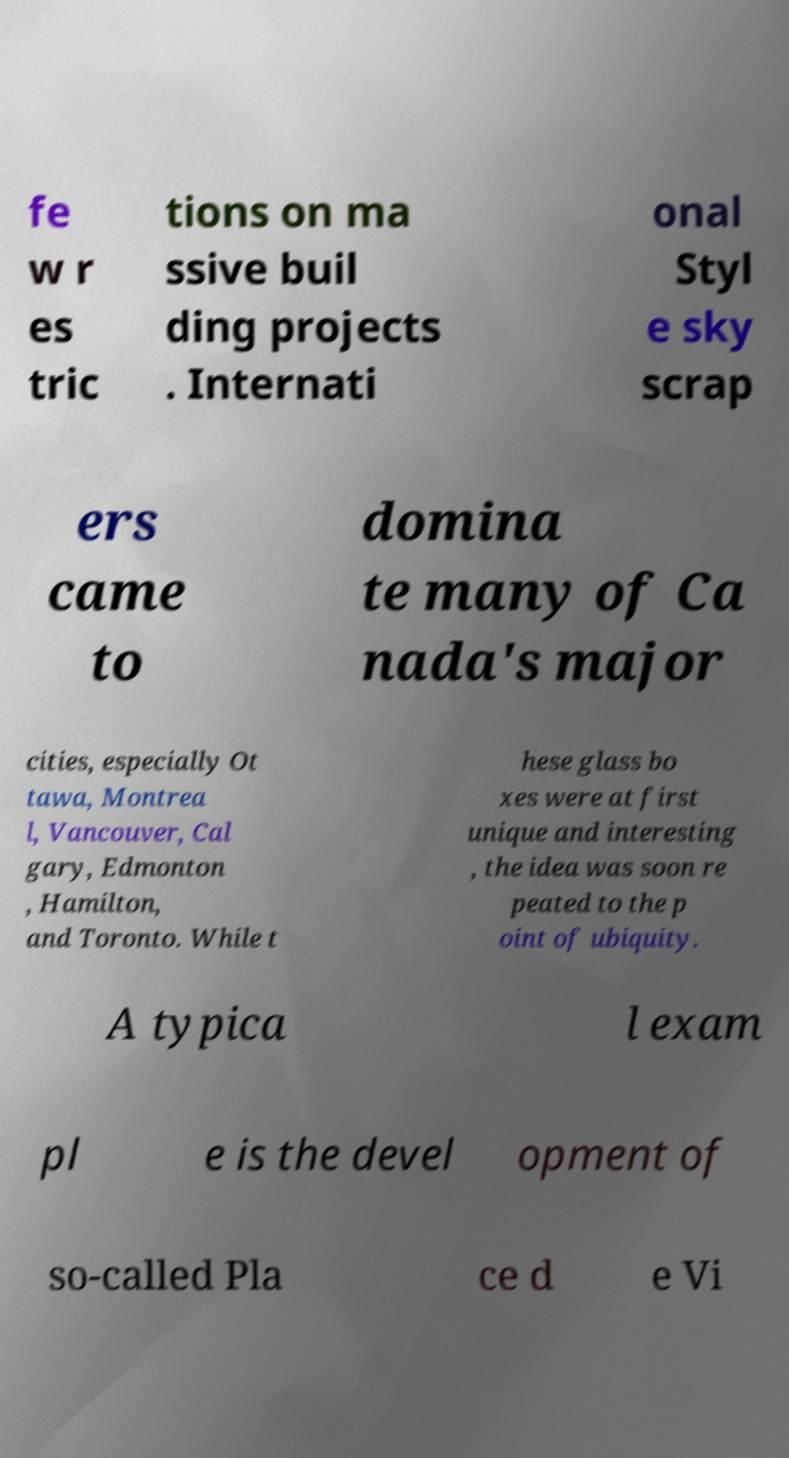Could you assist in decoding the text presented in this image and type it out clearly? fe w r es tric tions on ma ssive buil ding projects . Internati onal Styl e sky scrap ers came to domina te many of Ca nada's major cities, especially Ot tawa, Montrea l, Vancouver, Cal gary, Edmonton , Hamilton, and Toronto. While t hese glass bo xes were at first unique and interesting , the idea was soon re peated to the p oint of ubiquity. A typica l exam pl e is the devel opment of so-called Pla ce d e Vi 